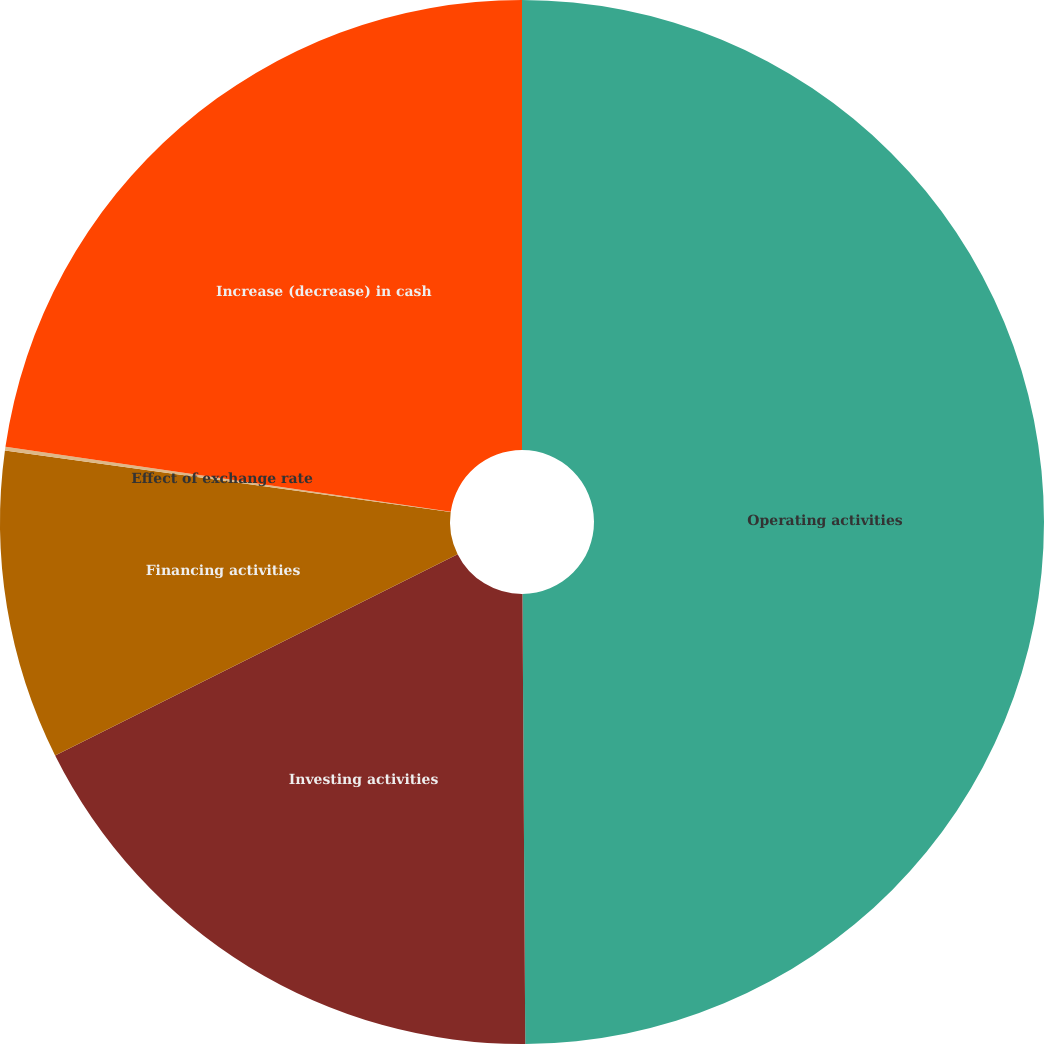Convert chart. <chart><loc_0><loc_0><loc_500><loc_500><pie_chart><fcel>Operating activities<fcel>Investing activities<fcel>Financing activities<fcel>Effect of exchange rate<fcel>Increase (decrease) in cash<nl><fcel>49.9%<fcel>17.72%<fcel>9.57%<fcel>0.11%<fcel>22.7%<nl></chart> 